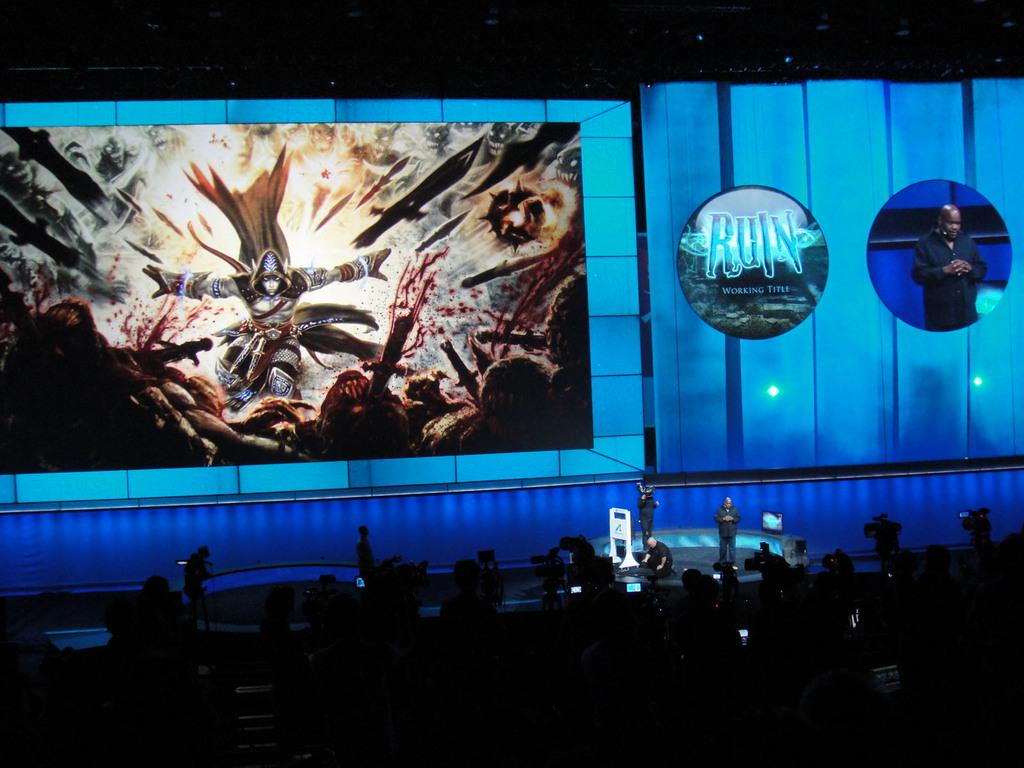What is the main focus of the image? The main focus of the image is the persons in the center. Can you describe the man in the image? There is a man standing on the stage on the right side of the image. What can be seen in the background of the image? There are graphics in the background of the image. What type of silver object is the man holding on the stage? There is no silver object visible in the image; the man is not holding anything. What advice is the man giving to the persons in the center? The image does not provide any information about the man giving advice to the persons in the center. 